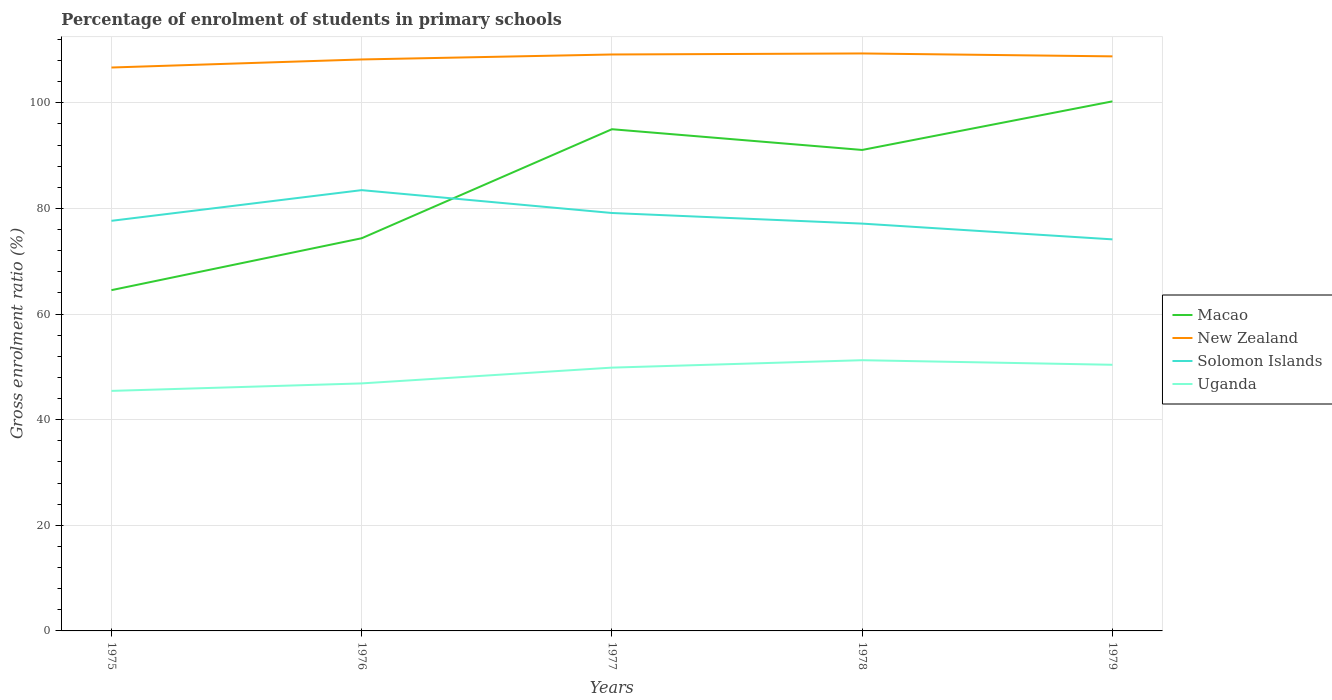How many different coloured lines are there?
Give a very brief answer. 4. Across all years, what is the maximum percentage of students enrolled in primary schools in Uganda?
Your response must be concise. 45.45. In which year was the percentage of students enrolled in primary schools in New Zealand maximum?
Ensure brevity in your answer.  1975. What is the total percentage of students enrolled in primary schools in Solomon Islands in the graph?
Ensure brevity in your answer.  2.98. What is the difference between the highest and the second highest percentage of students enrolled in primary schools in New Zealand?
Offer a very short reply. 2.66. What is the difference between the highest and the lowest percentage of students enrolled in primary schools in Solomon Islands?
Ensure brevity in your answer.  2. Is the percentage of students enrolled in primary schools in Uganda strictly greater than the percentage of students enrolled in primary schools in Solomon Islands over the years?
Offer a terse response. Yes. Does the graph contain grids?
Ensure brevity in your answer.  Yes. Where does the legend appear in the graph?
Your answer should be compact. Center right. How many legend labels are there?
Keep it short and to the point. 4. How are the legend labels stacked?
Keep it short and to the point. Vertical. What is the title of the graph?
Your response must be concise. Percentage of enrolment of students in primary schools. What is the label or title of the X-axis?
Keep it short and to the point. Years. What is the label or title of the Y-axis?
Provide a succinct answer. Gross enrolment ratio (%). What is the Gross enrolment ratio (%) of Macao in 1975?
Your response must be concise. 64.53. What is the Gross enrolment ratio (%) in New Zealand in 1975?
Offer a terse response. 106.69. What is the Gross enrolment ratio (%) of Solomon Islands in 1975?
Offer a very short reply. 77.66. What is the Gross enrolment ratio (%) in Uganda in 1975?
Keep it short and to the point. 45.45. What is the Gross enrolment ratio (%) in Macao in 1976?
Make the answer very short. 74.36. What is the Gross enrolment ratio (%) in New Zealand in 1976?
Your response must be concise. 108.21. What is the Gross enrolment ratio (%) in Solomon Islands in 1976?
Your answer should be compact. 83.47. What is the Gross enrolment ratio (%) of Uganda in 1976?
Make the answer very short. 46.87. What is the Gross enrolment ratio (%) of Macao in 1977?
Keep it short and to the point. 95. What is the Gross enrolment ratio (%) in New Zealand in 1977?
Your answer should be compact. 109.16. What is the Gross enrolment ratio (%) of Solomon Islands in 1977?
Provide a succinct answer. 79.14. What is the Gross enrolment ratio (%) in Uganda in 1977?
Offer a very short reply. 49.86. What is the Gross enrolment ratio (%) of Macao in 1978?
Keep it short and to the point. 91.08. What is the Gross enrolment ratio (%) in New Zealand in 1978?
Your answer should be very brief. 109.35. What is the Gross enrolment ratio (%) of Solomon Islands in 1978?
Keep it short and to the point. 77.13. What is the Gross enrolment ratio (%) in Uganda in 1978?
Provide a succinct answer. 51.26. What is the Gross enrolment ratio (%) in Macao in 1979?
Provide a short and direct response. 100.28. What is the Gross enrolment ratio (%) in New Zealand in 1979?
Provide a succinct answer. 108.8. What is the Gross enrolment ratio (%) of Solomon Islands in 1979?
Your response must be concise. 74.15. What is the Gross enrolment ratio (%) in Uganda in 1979?
Make the answer very short. 50.4. Across all years, what is the maximum Gross enrolment ratio (%) in Macao?
Your answer should be very brief. 100.28. Across all years, what is the maximum Gross enrolment ratio (%) of New Zealand?
Give a very brief answer. 109.35. Across all years, what is the maximum Gross enrolment ratio (%) in Solomon Islands?
Provide a succinct answer. 83.47. Across all years, what is the maximum Gross enrolment ratio (%) of Uganda?
Your answer should be very brief. 51.26. Across all years, what is the minimum Gross enrolment ratio (%) of Macao?
Your answer should be compact. 64.53. Across all years, what is the minimum Gross enrolment ratio (%) in New Zealand?
Make the answer very short. 106.69. Across all years, what is the minimum Gross enrolment ratio (%) of Solomon Islands?
Your response must be concise. 74.15. Across all years, what is the minimum Gross enrolment ratio (%) of Uganda?
Give a very brief answer. 45.45. What is the total Gross enrolment ratio (%) in Macao in the graph?
Offer a very short reply. 425.25. What is the total Gross enrolment ratio (%) of New Zealand in the graph?
Keep it short and to the point. 542.21. What is the total Gross enrolment ratio (%) in Solomon Islands in the graph?
Keep it short and to the point. 391.54. What is the total Gross enrolment ratio (%) of Uganda in the graph?
Your response must be concise. 243.84. What is the difference between the Gross enrolment ratio (%) of Macao in 1975 and that in 1976?
Offer a very short reply. -9.83. What is the difference between the Gross enrolment ratio (%) in New Zealand in 1975 and that in 1976?
Make the answer very short. -1.53. What is the difference between the Gross enrolment ratio (%) in Solomon Islands in 1975 and that in 1976?
Your answer should be compact. -5.81. What is the difference between the Gross enrolment ratio (%) in Uganda in 1975 and that in 1976?
Offer a terse response. -1.42. What is the difference between the Gross enrolment ratio (%) in Macao in 1975 and that in 1977?
Your answer should be compact. -30.47. What is the difference between the Gross enrolment ratio (%) of New Zealand in 1975 and that in 1977?
Make the answer very short. -2.47. What is the difference between the Gross enrolment ratio (%) in Solomon Islands in 1975 and that in 1977?
Offer a terse response. -1.48. What is the difference between the Gross enrolment ratio (%) in Uganda in 1975 and that in 1977?
Make the answer very short. -4.41. What is the difference between the Gross enrolment ratio (%) in Macao in 1975 and that in 1978?
Offer a terse response. -26.55. What is the difference between the Gross enrolment ratio (%) of New Zealand in 1975 and that in 1978?
Make the answer very short. -2.66. What is the difference between the Gross enrolment ratio (%) of Solomon Islands in 1975 and that in 1978?
Ensure brevity in your answer.  0.53. What is the difference between the Gross enrolment ratio (%) in Uganda in 1975 and that in 1978?
Keep it short and to the point. -5.81. What is the difference between the Gross enrolment ratio (%) in Macao in 1975 and that in 1979?
Offer a very short reply. -35.75. What is the difference between the Gross enrolment ratio (%) in New Zealand in 1975 and that in 1979?
Offer a terse response. -2.11. What is the difference between the Gross enrolment ratio (%) in Solomon Islands in 1975 and that in 1979?
Provide a succinct answer. 3.51. What is the difference between the Gross enrolment ratio (%) of Uganda in 1975 and that in 1979?
Your answer should be very brief. -4.95. What is the difference between the Gross enrolment ratio (%) in Macao in 1976 and that in 1977?
Keep it short and to the point. -20.64. What is the difference between the Gross enrolment ratio (%) of New Zealand in 1976 and that in 1977?
Ensure brevity in your answer.  -0.94. What is the difference between the Gross enrolment ratio (%) of Solomon Islands in 1976 and that in 1977?
Offer a terse response. 4.33. What is the difference between the Gross enrolment ratio (%) of Uganda in 1976 and that in 1977?
Make the answer very short. -2.99. What is the difference between the Gross enrolment ratio (%) of Macao in 1976 and that in 1978?
Offer a very short reply. -16.72. What is the difference between the Gross enrolment ratio (%) in New Zealand in 1976 and that in 1978?
Provide a short and direct response. -1.14. What is the difference between the Gross enrolment ratio (%) of Solomon Islands in 1976 and that in 1978?
Provide a succinct answer. 6.34. What is the difference between the Gross enrolment ratio (%) in Uganda in 1976 and that in 1978?
Give a very brief answer. -4.39. What is the difference between the Gross enrolment ratio (%) of Macao in 1976 and that in 1979?
Offer a very short reply. -25.92. What is the difference between the Gross enrolment ratio (%) in New Zealand in 1976 and that in 1979?
Your answer should be compact. -0.58. What is the difference between the Gross enrolment ratio (%) in Solomon Islands in 1976 and that in 1979?
Give a very brief answer. 9.32. What is the difference between the Gross enrolment ratio (%) of Uganda in 1976 and that in 1979?
Ensure brevity in your answer.  -3.53. What is the difference between the Gross enrolment ratio (%) of Macao in 1977 and that in 1978?
Your response must be concise. 3.93. What is the difference between the Gross enrolment ratio (%) of New Zealand in 1977 and that in 1978?
Your response must be concise. -0.2. What is the difference between the Gross enrolment ratio (%) of Solomon Islands in 1977 and that in 1978?
Give a very brief answer. 2.01. What is the difference between the Gross enrolment ratio (%) of Uganda in 1977 and that in 1978?
Ensure brevity in your answer.  -1.4. What is the difference between the Gross enrolment ratio (%) in Macao in 1977 and that in 1979?
Keep it short and to the point. -5.27. What is the difference between the Gross enrolment ratio (%) of New Zealand in 1977 and that in 1979?
Your response must be concise. 0.36. What is the difference between the Gross enrolment ratio (%) in Solomon Islands in 1977 and that in 1979?
Your response must be concise. 4.99. What is the difference between the Gross enrolment ratio (%) of Uganda in 1977 and that in 1979?
Provide a short and direct response. -0.54. What is the difference between the Gross enrolment ratio (%) in Macao in 1978 and that in 1979?
Give a very brief answer. -9.2. What is the difference between the Gross enrolment ratio (%) in New Zealand in 1978 and that in 1979?
Keep it short and to the point. 0.55. What is the difference between the Gross enrolment ratio (%) in Solomon Islands in 1978 and that in 1979?
Ensure brevity in your answer.  2.98. What is the difference between the Gross enrolment ratio (%) in Uganda in 1978 and that in 1979?
Provide a short and direct response. 0.87. What is the difference between the Gross enrolment ratio (%) in Macao in 1975 and the Gross enrolment ratio (%) in New Zealand in 1976?
Provide a short and direct response. -43.68. What is the difference between the Gross enrolment ratio (%) of Macao in 1975 and the Gross enrolment ratio (%) of Solomon Islands in 1976?
Offer a terse response. -18.94. What is the difference between the Gross enrolment ratio (%) in Macao in 1975 and the Gross enrolment ratio (%) in Uganda in 1976?
Give a very brief answer. 17.66. What is the difference between the Gross enrolment ratio (%) in New Zealand in 1975 and the Gross enrolment ratio (%) in Solomon Islands in 1976?
Offer a terse response. 23.22. What is the difference between the Gross enrolment ratio (%) in New Zealand in 1975 and the Gross enrolment ratio (%) in Uganda in 1976?
Offer a very short reply. 59.82. What is the difference between the Gross enrolment ratio (%) in Solomon Islands in 1975 and the Gross enrolment ratio (%) in Uganda in 1976?
Offer a terse response. 30.79. What is the difference between the Gross enrolment ratio (%) in Macao in 1975 and the Gross enrolment ratio (%) in New Zealand in 1977?
Make the answer very short. -44.63. What is the difference between the Gross enrolment ratio (%) of Macao in 1975 and the Gross enrolment ratio (%) of Solomon Islands in 1977?
Your response must be concise. -14.61. What is the difference between the Gross enrolment ratio (%) of Macao in 1975 and the Gross enrolment ratio (%) of Uganda in 1977?
Make the answer very short. 14.67. What is the difference between the Gross enrolment ratio (%) of New Zealand in 1975 and the Gross enrolment ratio (%) of Solomon Islands in 1977?
Make the answer very short. 27.55. What is the difference between the Gross enrolment ratio (%) of New Zealand in 1975 and the Gross enrolment ratio (%) of Uganda in 1977?
Provide a succinct answer. 56.83. What is the difference between the Gross enrolment ratio (%) of Solomon Islands in 1975 and the Gross enrolment ratio (%) of Uganda in 1977?
Your answer should be compact. 27.8. What is the difference between the Gross enrolment ratio (%) of Macao in 1975 and the Gross enrolment ratio (%) of New Zealand in 1978?
Provide a succinct answer. -44.82. What is the difference between the Gross enrolment ratio (%) in Macao in 1975 and the Gross enrolment ratio (%) in Solomon Islands in 1978?
Keep it short and to the point. -12.6. What is the difference between the Gross enrolment ratio (%) in Macao in 1975 and the Gross enrolment ratio (%) in Uganda in 1978?
Provide a short and direct response. 13.27. What is the difference between the Gross enrolment ratio (%) in New Zealand in 1975 and the Gross enrolment ratio (%) in Solomon Islands in 1978?
Your response must be concise. 29.56. What is the difference between the Gross enrolment ratio (%) of New Zealand in 1975 and the Gross enrolment ratio (%) of Uganda in 1978?
Your answer should be very brief. 55.43. What is the difference between the Gross enrolment ratio (%) in Solomon Islands in 1975 and the Gross enrolment ratio (%) in Uganda in 1978?
Offer a terse response. 26.39. What is the difference between the Gross enrolment ratio (%) of Macao in 1975 and the Gross enrolment ratio (%) of New Zealand in 1979?
Offer a very short reply. -44.27. What is the difference between the Gross enrolment ratio (%) of Macao in 1975 and the Gross enrolment ratio (%) of Solomon Islands in 1979?
Make the answer very short. -9.62. What is the difference between the Gross enrolment ratio (%) of Macao in 1975 and the Gross enrolment ratio (%) of Uganda in 1979?
Provide a short and direct response. 14.13. What is the difference between the Gross enrolment ratio (%) in New Zealand in 1975 and the Gross enrolment ratio (%) in Solomon Islands in 1979?
Your response must be concise. 32.54. What is the difference between the Gross enrolment ratio (%) of New Zealand in 1975 and the Gross enrolment ratio (%) of Uganda in 1979?
Ensure brevity in your answer.  56.29. What is the difference between the Gross enrolment ratio (%) in Solomon Islands in 1975 and the Gross enrolment ratio (%) in Uganda in 1979?
Offer a very short reply. 27.26. What is the difference between the Gross enrolment ratio (%) in Macao in 1976 and the Gross enrolment ratio (%) in New Zealand in 1977?
Provide a short and direct response. -34.8. What is the difference between the Gross enrolment ratio (%) in Macao in 1976 and the Gross enrolment ratio (%) in Solomon Islands in 1977?
Ensure brevity in your answer.  -4.78. What is the difference between the Gross enrolment ratio (%) in Macao in 1976 and the Gross enrolment ratio (%) in Uganda in 1977?
Your answer should be compact. 24.5. What is the difference between the Gross enrolment ratio (%) in New Zealand in 1976 and the Gross enrolment ratio (%) in Solomon Islands in 1977?
Your answer should be compact. 29.07. What is the difference between the Gross enrolment ratio (%) of New Zealand in 1976 and the Gross enrolment ratio (%) of Uganda in 1977?
Keep it short and to the point. 58.35. What is the difference between the Gross enrolment ratio (%) in Solomon Islands in 1976 and the Gross enrolment ratio (%) in Uganda in 1977?
Your response must be concise. 33.61. What is the difference between the Gross enrolment ratio (%) in Macao in 1976 and the Gross enrolment ratio (%) in New Zealand in 1978?
Provide a succinct answer. -34.99. What is the difference between the Gross enrolment ratio (%) in Macao in 1976 and the Gross enrolment ratio (%) in Solomon Islands in 1978?
Your response must be concise. -2.77. What is the difference between the Gross enrolment ratio (%) of Macao in 1976 and the Gross enrolment ratio (%) of Uganda in 1978?
Make the answer very short. 23.1. What is the difference between the Gross enrolment ratio (%) in New Zealand in 1976 and the Gross enrolment ratio (%) in Solomon Islands in 1978?
Make the answer very short. 31.09. What is the difference between the Gross enrolment ratio (%) of New Zealand in 1976 and the Gross enrolment ratio (%) of Uganda in 1978?
Provide a succinct answer. 56.95. What is the difference between the Gross enrolment ratio (%) of Solomon Islands in 1976 and the Gross enrolment ratio (%) of Uganda in 1978?
Your response must be concise. 32.2. What is the difference between the Gross enrolment ratio (%) in Macao in 1976 and the Gross enrolment ratio (%) in New Zealand in 1979?
Offer a very short reply. -34.44. What is the difference between the Gross enrolment ratio (%) of Macao in 1976 and the Gross enrolment ratio (%) of Solomon Islands in 1979?
Provide a succinct answer. 0.21. What is the difference between the Gross enrolment ratio (%) in Macao in 1976 and the Gross enrolment ratio (%) in Uganda in 1979?
Your answer should be compact. 23.96. What is the difference between the Gross enrolment ratio (%) of New Zealand in 1976 and the Gross enrolment ratio (%) of Solomon Islands in 1979?
Your answer should be compact. 34.07. What is the difference between the Gross enrolment ratio (%) in New Zealand in 1976 and the Gross enrolment ratio (%) in Uganda in 1979?
Provide a succinct answer. 57.82. What is the difference between the Gross enrolment ratio (%) in Solomon Islands in 1976 and the Gross enrolment ratio (%) in Uganda in 1979?
Ensure brevity in your answer.  33.07. What is the difference between the Gross enrolment ratio (%) in Macao in 1977 and the Gross enrolment ratio (%) in New Zealand in 1978?
Your response must be concise. -14.35. What is the difference between the Gross enrolment ratio (%) in Macao in 1977 and the Gross enrolment ratio (%) in Solomon Islands in 1978?
Give a very brief answer. 17.88. What is the difference between the Gross enrolment ratio (%) in Macao in 1977 and the Gross enrolment ratio (%) in Uganda in 1978?
Your answer should be compact. 43.74. What is the difference between the Gross enrolment ratio (%) in New Zealand in 1977 and the Gross enrolment ratio (%) in Solomon Islands in 1978?
Ensure brevity in your answer.  32.03. What is the difference between the Gross enrolment ratio (%) of New Zealand in 1977 and the Gross enrolment ratio (%) of Uganda in 1978?
Keep it short and to the point. 57.89. What is the difference between the Gross enrolment ratio (%) in Solomon Islands in 1977 and the Gross enrolment ratio (%) in Uganda in 1978?
Give a very brief answer. 27.88. What is the difference between the Gross enrolment ratio (%) of Macao in 1977 and the Gross enrolment ratio (%) of New Zealand in 1979?
Make the answer very short. -13.8. What is the difference between the Gross enrolment ratio (%) of Macao in 1977 and the Gross enrolment ratio (%) of Solomon Islands in 1979?
Keep it short and to the point. 20.86. What is the difference between the Gross enrolment ratio (%) of Macao in 1977 and the Gross enrolment ratio (%) of Uganda in 1979?
Provide a succinct answer. 44.61. What is the difference between the Gross enrolment ratio (%) in New Zealand in 1977 and the Gross enrolment ratio (%) in Solomon Islands in 1979?
Your response must be concise. 35.01. What is the difference between the Gross enrolment ratio (%) of New Zealand in 1977 and the Gross enrolment ratio (%) of Uganda in 1979?
Your answer should be very brief. 58.76. What is the difference between the Gross enrolment ratio (%) of Solomon Islands in 1977 and the Gross enrolment ratio (%) of Uganda in 1979?
Give a very brief answer. 28.74. What is the difference between the Gross enrolment ratio (%) of Macao in 1978 and the Gross enrolment ratio (%) of New Zealand in 1979?
Offer a very short reply. -17.72. What is the difference between the Gross enrolment ratio (%) in Macao in 1978 and the Gross enrolment ratio (%) in Solomon Islands in 1979?
Offer a very short reply. 16.93. What is the difference between the Gross enrolment ratio (%) in Macao in 1978 and the Gross enrolment ratio (%) in Uganda in 1979?
Your response must be concise. 40.68. What is the difference between the Gross enrolment ratio (%) of New Zealand in 1978 and the Gross enrolment ratio (%) of Solomon Islands in 1979?
Provide a short and direct response. 35.21. What is the difference between the Gross enrolment ratio (%) in New Zealand in 1978 and the Gross enrolment ratio (%) in Uganda in 1979?
Provide a succinct answer. 58.95. What is the difference between the Gross enrolment ratio (%) in Solomon Islands in 1978 and the Gross enrolment ratio (%) in Uganda in 1979?
Offer a very short reply. 26.73. What is the average Gross enrolment ratio (%) of Macao per year?
Your answer should be compact. 85.05. What is the average Gross enrolment ratio (%) of New Zealand per year?
Offer a terse response. 108.44. What is the average Gross enrolment ratio (%) in Solomon Islands per year?
Offer a very short reply. 78.31. What is the average Gross enrolment ratio (%) in Uganda per year?
Provide a succinct answer. 48.77. In the year 1975, what is the difference between the Gross enrolment ratio (%) of Macao and Gross enrolment ratio (%) of New Zealand?
Your answer should be compact. -42.16. In the year 1975, what is the difference between the Gross enrolment ratio (%) of Macao and Gross enrolment ratio (%) of Solomon Islands?
Ensure brevity in your answer.  -13.13. In the year 1975, what is the difference between the Gross enrolment ratio (%) in Macao and Gross enrolment ratio (%) in Uganda?
Give a very brief answer. 19.08. In the year 1975, what is the difference between the Gross enrolment ratio (%) in New Zealand and Gross enrolment ratio (%) in Solomon Islands?
Your answer should be very brief. 29.03. In the year 1975, what is the difference between the Gross enrolment ratio (%) of New Zealand and Gross enrolment ratio (%) of Uganda?
Ensure brevity in your answer.  61.24. In the year 1975, what is the difference between the Gross enrolment ratio (%) of Solomon Islands and Gross enrolment ratio (%) of Uganda?
Make the answer very short. 32.2. In the year 1976, what is the difference between the Gross enrolment ratio (%) of Macao and Gross enrolment ratio (%) of New Zealand?
Make the answer very short. -33.86. In the year 1976, what is the difference between the Gross enrolment ratio (%) of Macao and Gross enrolment ratio (%) of Solomon Islands?
Offer a terse response. -9.11. In the year 1976, what is the difference between the Gross enrolment ratio (%) of Macao and Gross enrolment ratio (%) of Uganda?
Give a very brief answer. 27.49. In the year 1976, what is the difference between the Gross enrolment ratio (%) in New Zealand and Gross enrolment ratio (%) in Solomon Islands?
Keep it short and to the point. 24.75. In the year 1976, what is the difference between the Gross enrolment ratio (%) in New Zealand and Gross enrolment ratio (%) in Uganda?
Your response must be concise. 61.34. In the year 1976, what is the difference between the Gross enrolment ratio (%) in Solomon Islands and Gross enrolment ratio (%) in Uganda?
Your answer should be very brief. 36.6. In the year 1977, what is the difference between the Gross enrolment ratio (%) in Macao and Gross enrolment ratio (%) in New Zealand?
Keep it short and to the point. -14.15. In the year 1977, what is the difference between the Gross enrolment ratio (%) of Macao and Gross enrolment ratio (%) of Solomon Islands?
Give a very brief answer. 15.86. In the year 1977, what is the difference between the Gross enrolment ratio (%) in Macao and Gross enrolment ratio (%) in Uganda?
Keep it short and to the point. 45.14. In the year 1977, what is the difference between the Gross enrolment ratio (%) of New Zealand and Gross enrolment ratio (%) of Solomon Islands?
Provide a short and direct response. 30.02. In the year 1977, what is the difference between the Gross enrolment ratio (%) of New Zealand and Gross enrolment ratio (%) of Uganda?
Offer a very short reply. 59.3. In the year 1977, what is the difference between the Gross enrolment ratio (%) of Solomon Islands and Gross enrolment ratio (%) of Uganda?
Offer a terse response. 29.28. In the year 1978, what is the difference between the Gross enrolment ratio (%) of Macao and Gross enrolment ratio (%) of New Zealand?
Make the answer very short. -18.27. In the year 1978, what is the difference between the Gross enrolment ratio (%) of Macao and Gross enrolment ratio (%) of Solomon Islands?
Provide a succinct answer. 13.95. In the year 1978, what is the difference between the Gross enrolment ratio (%) of Macao and Gross enrolment ratio (%) of Uganda?
Your response must be concise. 39.81. In the year 1978, what is the difference between the Gross enrolment ratio (%) in New Zealand and Gross enrolment ratio (%) in Solomon Islands?
Make the answer very short. 32.22. In the year 1978, what is the difference between the Gross enrolment ratio (%) of New Zealand and Gross enrolment ratio (%) of Uganda?
Ensure brevity in your answer.  58.09. In the year 1978, what is the difference between the Gross enrolment ratio (%) in Solomon Islands and Gross enrolment ratio (%) in Uganda?
Your answer should be very brief. 25.87. In the year 1979, what is the difference between the Gross enrolment ratio (%) in Macao and Gross enrolment ratio (%) in New Zealand?
Make the answer very short. -8.52. In the year 1979, what is the difference between the Gross enrolment ratio (%) of Macao and Gross enrolment ratio (%) of Solomon Islands?
Keep it short and to the point. 26.13. In the year 1979, what is the difference between the Gross enrolment ratio (%) of Macao and Gross enrolment ratio (%) of Uganda?
Provide a short and direct response. 49.88. In the year 1979, what is the difference between the Gross enrolment ratio (%) of New Zealand and Gross enrolment ratio (%) of Solomon Islands?
Your answer should be very brief. 34.65. In the year 1979, what is the difference between the Gross enrolment ratio (%) in New Zealand and Gross enrolment ratio (%) in Uganda?
Your response must be concise. 58.4. In the year 1979, what is the difference between the Gross enrolment ratio (%) of Solomon Islands and Gross enrolment ratio (%) of Uganda?
Give a very brief answer. 23.75. What is the ratio of the Gross enrolment ratio (%) of Macao in 1975 to that in 1976?
Ensure brevity in your answer.  0.87. What is the ratio of the Gross enrolment ratio (%) in New Zealand in 1975 to that in 1976?
Offer a terse response. 0.99. What is the ratio of the Gross enrolment ratio (%) of Solomon Islands in 1975 to that in 1976?
Make the answer very short. 0.93. What is the ratio of the Gross enrolment ratio (%) in Uganda in 1975 to that in 1976?
Your answer should be very brief. 0.97. What is the ratio of the Gross enrolment ratio (%) of Macao in 1975 to that in 1977?
Offer a terse response. 0.68. What is the ratio of the Gross enrolment ratio (%) of New Zealand in 1975 to that in 1977?
Offer a terse response. 0.98. What is the ratio of the Gross enrolment ratio (%) in Solomon Islands in 1975 to that in 1977?
Ensure brevity in your answer.  0.98. What is the ratio of the Gross enrolment ratio (%) of Uganda in 1975 to that in 1977?
Your response must be concise. 0.91. What is the ratio of the Gross enrolment ratio (%) of Macao in 1975 to that in 1978?
Provide a succinct answer. 0.71. What is the ratio of the Gross enrolment ratio (%) in New Zealand in 1975 to that in 1978?
Keep it short and to the point. 0.98. What is the ratio of the Gross enrolment ratio (%) of Solomon Islands in 1975 to that in 1978?
Offer a very short reply. 1.01. What is the ratio of the Gross enrolment ratio (%) of Uganda in 1975 to that in 1978?
Your answer should be very brief. 0.89. What is the ratio of the Gross enrolment ratio (%) of Macao in 1975 to that in 1979?
Offer a very short reply. 0.64. What is the ratio of the Gross enrolment ratio (%) of New Zealand in 1975 to that in 1979?
Ensure brevity in your answer.  0.98. What is the ratio of the Gross enrolment ratio (%) of Solomon Islands in 1975 to that in 1979?
Make the answer very short. 1.05. What is the ratio of the Gross enrolment ratio (%) in Uganda in 1975 to that in 1979?
Keep it short and to the point. 0.9. What is the ratio of the Gross enrolment ratio (%) of Macao in 1976 to that in 1977?
Your answer should be very brief. 0.78. What is the ratio of the Gross enrolment ratio (%) in New Zealand in 1976 to that in 1977?
Your response must be concise. 0.99. What is the ratio of the Gross enrolment ratio (%) of Solomon Islands in 1976 to that in 1977?
Give a very brief answer. 1.05. What is the ratio of the Gross enrolment ratio (%) in Uganda in 1976 to that in 1977?
Provide a succinct answer. 0.94. What is the ratio of the Gross enrolment ratio (%) of Macao in 1976 to that in 1978?
Offer a terse response. 0.82. What is the ratio of the Gross enrolment ratio (%) in Solomon Islands in 1976 to that in 1978?
Your answer should be compact. 1.08. What is the ratio of the Gross enrolment ratio (%) of Uganda in 1976 to that in 1978?
Provide a succinct answer. 0.91. What is the ratio of the Gross enrolment ratio (%) in Macao in 1976 to that in 1979?
Offer a very short reply. 0.74. What is the ratio of the Gross enrolment ratio (%) in Solomon Islands in 1976 to that in 1979?
Your answer should be very brief. 1.13. What is the ratio of the Gross enrolment ratio (%) of Uganda in 1976 to that in 1979?
Provide a succinct answer. 0.93. What is the ratio of the Gross enrolment ratio (%) of Macao in 1977 to that in 1978?
Offer a terse response. 1.04. What is the ratio of the Gross enrolment ratio (%) in Solomon Islands in 1977 to that in 1978?
Keep it short and to the point. 1.03. What is the ratio of the Gross enrolment ratio (%) in Uganda in 1977 to that in 1978?
Give a very brief answer. 0.97. What is the ratio of the Gross enrolment ratio (%) in New Zealand in 1977 to that in 1979?
Offer a very short reply. 1. What is the ratio of the Gross enrolment ratio (%) of Solomon Islands in 1977 to that in 1979?
Offer a terse response. 1.07. What is the ratio of the Gross enrolment ratio (%) of Uganda in 1977 to that in 1979?
Your response must be concise. 0.99. What is the ratio of the Gross enrolment ratio (%) of Macao in 1978 to that in 1979?
Your response must be concise. 0.91. What is the ratio of the Gross enrolment ratio (%) in New Zealand in 1978 to that in 1979?
Offer a very short reply. 1.01. What is the ratio of the Gross enrolment ratio (%) of Solomon Islands in 1978 to that in 1979?
Give a very brief answer. 1.04. What is the ratio of the Gross enrolment ratio (%) of Uganda in 1978 to that in 1979?
Keep it short and to the point. 1.02. What is the difference between the highest and the second highest Gross enrolment ratio (%) in Macao?
Ensure brevity in your answer.  5.27. What is the difference between the highest and the second highest Gross enrolment ratio (%) of New Zealand?
Your response must be concise. 0.2. What is the difference between the highest and the second highest Gross enrolment ratio (%) in Solomon Islands?
Keep it short and to the point. 4.33. What is the difference between the highest and the second highest Gross enrolment ratio (%) in Uganda?
Your answer should be compact. 0.87. What is the difference between the highest and the lowest Gross enrolment ratio (%) of Macao?
Offer a terse response. 35.75. What is the difference between the highest and the lowest Gross enrolment ratio (%) of New Zealand?
Your response must be concise. 2.66. What is the difference between the highest and the lowest Gross enrolment ratio (%) of Solomon Islands?
Provide a short and direct response. 9.32. What is the difference between the highest and the lowest Gross enrolment ratio (%) of Uganda?
Make the answer very short. 5.81. 